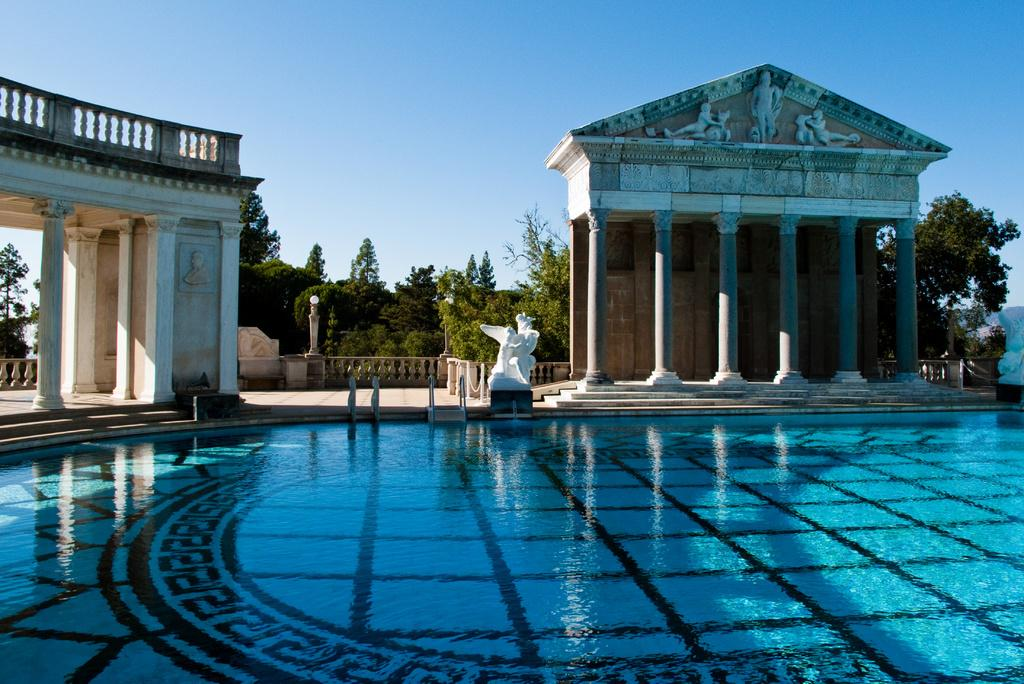What is located at the bottom of the image? There is a swimming pool at the bottom of the image. What can be seen in the middle of the image? There are statues in the middle of the image. What type of vegetation is present in the image? There are trees in the image. What is visible at the top of the image? The sky is visible at the top of the image. What type of teaching is taking place in the image? There is no teaching activity depicted in the image. How many protestors can be seen in the image? There are no protestors present in the image. 